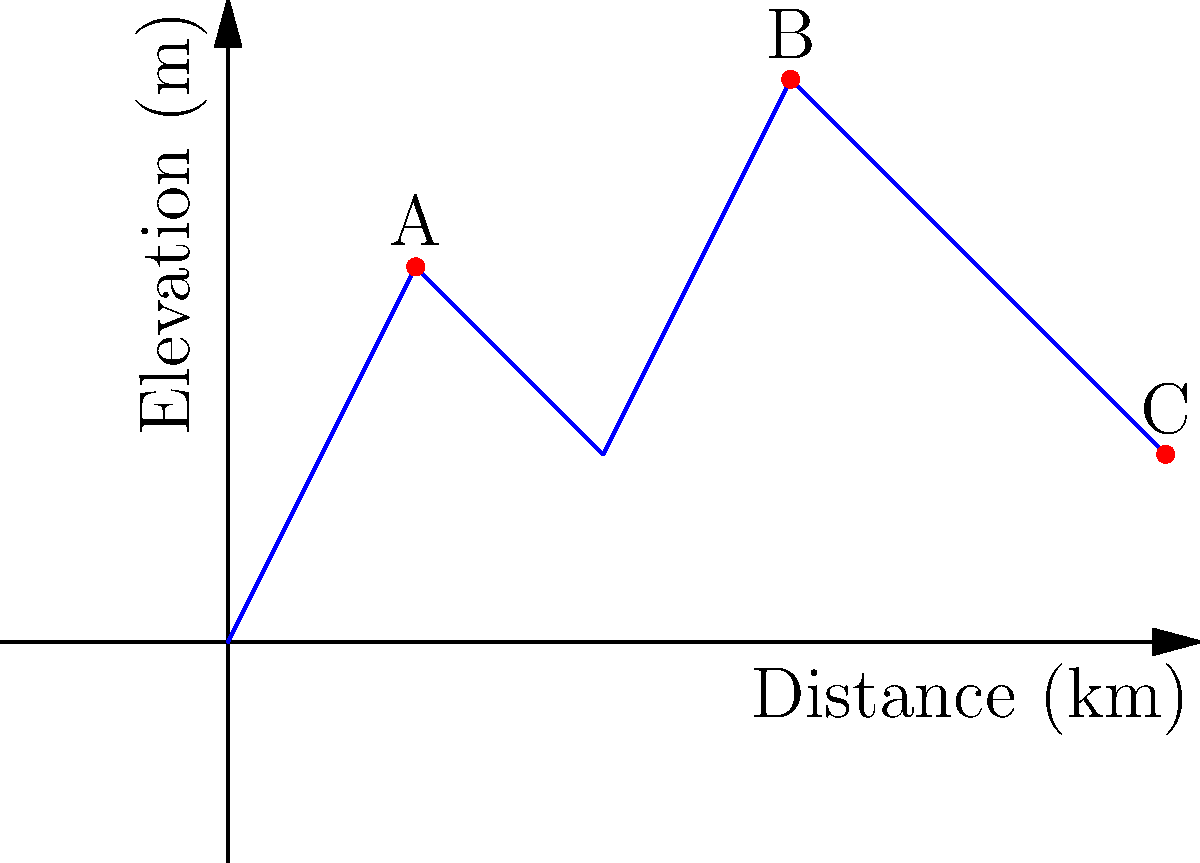Based on the elevation profile of your farmland affected by mining activities, which location (A, B, or C) would be the most effective for installing a water filtration system to minimize contamination spread? To determine the most effective location for a water filtration system, we need to consider the following factors:

1. Elevation: Higher elevations are generally better for filtration systems as they allow gravity to assist in water distribution.
2. Proximity to potential contamination sources: The system should be placed upstream from likely contamination points.
3. Coverage area: The chosen location should be able to serve the largest possible area of farmland.

Analyzing the given elevation profile:

1. Point A (1 km, 2 m): 
   - Moderate elevation
   - Near the beginning of the profile, which could be upstream from mining activities

2. Point B (3 km, 3 m):
   - Highest elevation among the options
   - Central location, providing good coverage for the entire area

3. Point C (5 km, 1 m):
   - Lowest elevation
   - At the far end of the profile, potentially downstream from mining activities

Considering these factors, Point B (3 km, 3 m) is the most effective location because:
- It has the highest elevation, allowing for gravity-assisted water distribution.
- Its central location provides the best coverage for the entire farmland.
- Being at the highest point, it's less likely to be affected by contamination from upstream sources.
Answer: Point B (3 km, 3 m) 